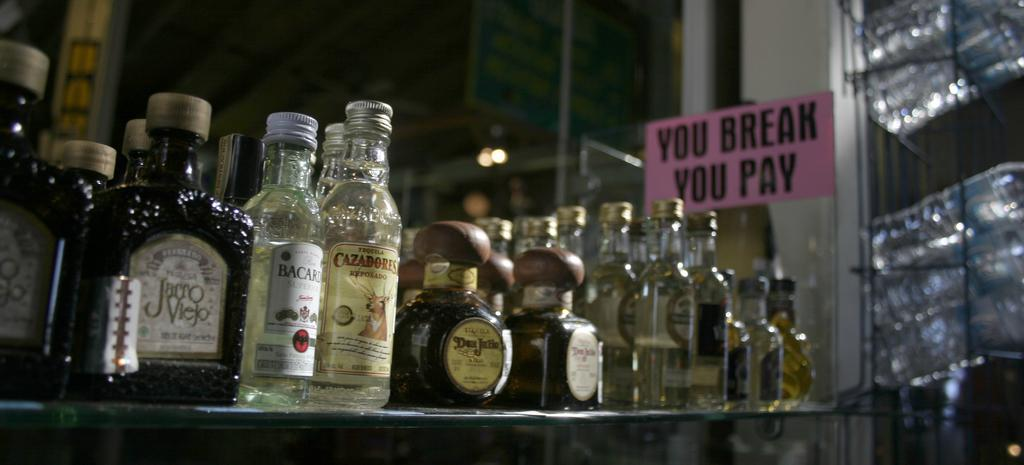<image>
Write a terse but informative summary of the picture. The sign in the bar says you break you pay 